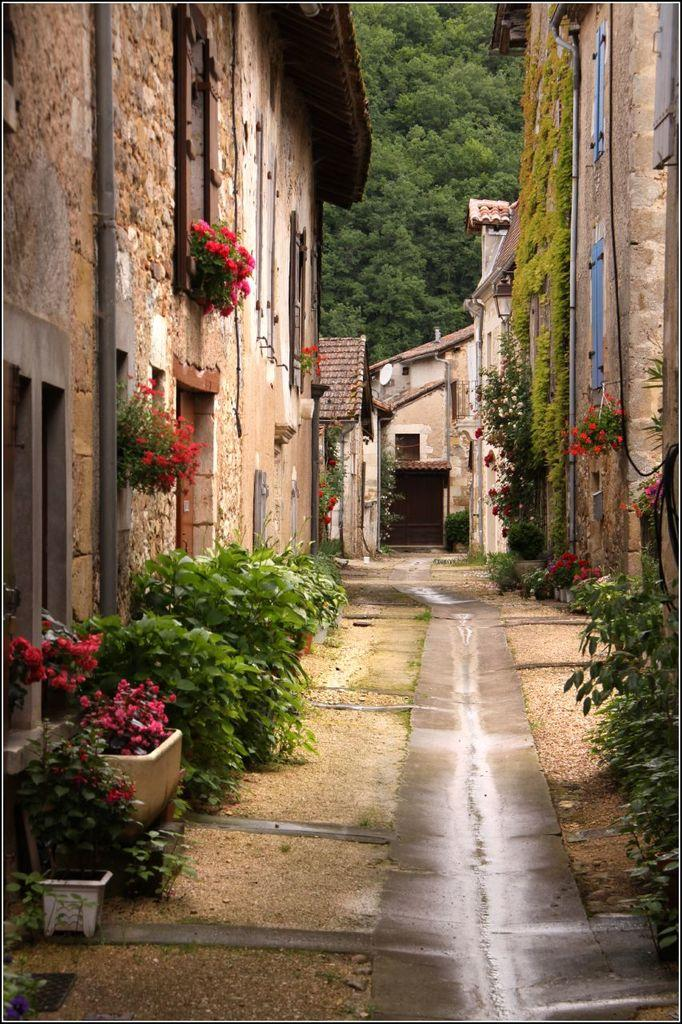What type of structures can be seen in the image? There are buildings in the image. Can you describe the area between the buildings? There is a path between the buildings. What kind of vegetation is present around the path? There are many flower plants around the path. How many trees can be seen near the hydrant in the image? There is no hydrant present in the image, and therefore no trees can be seen near it. 